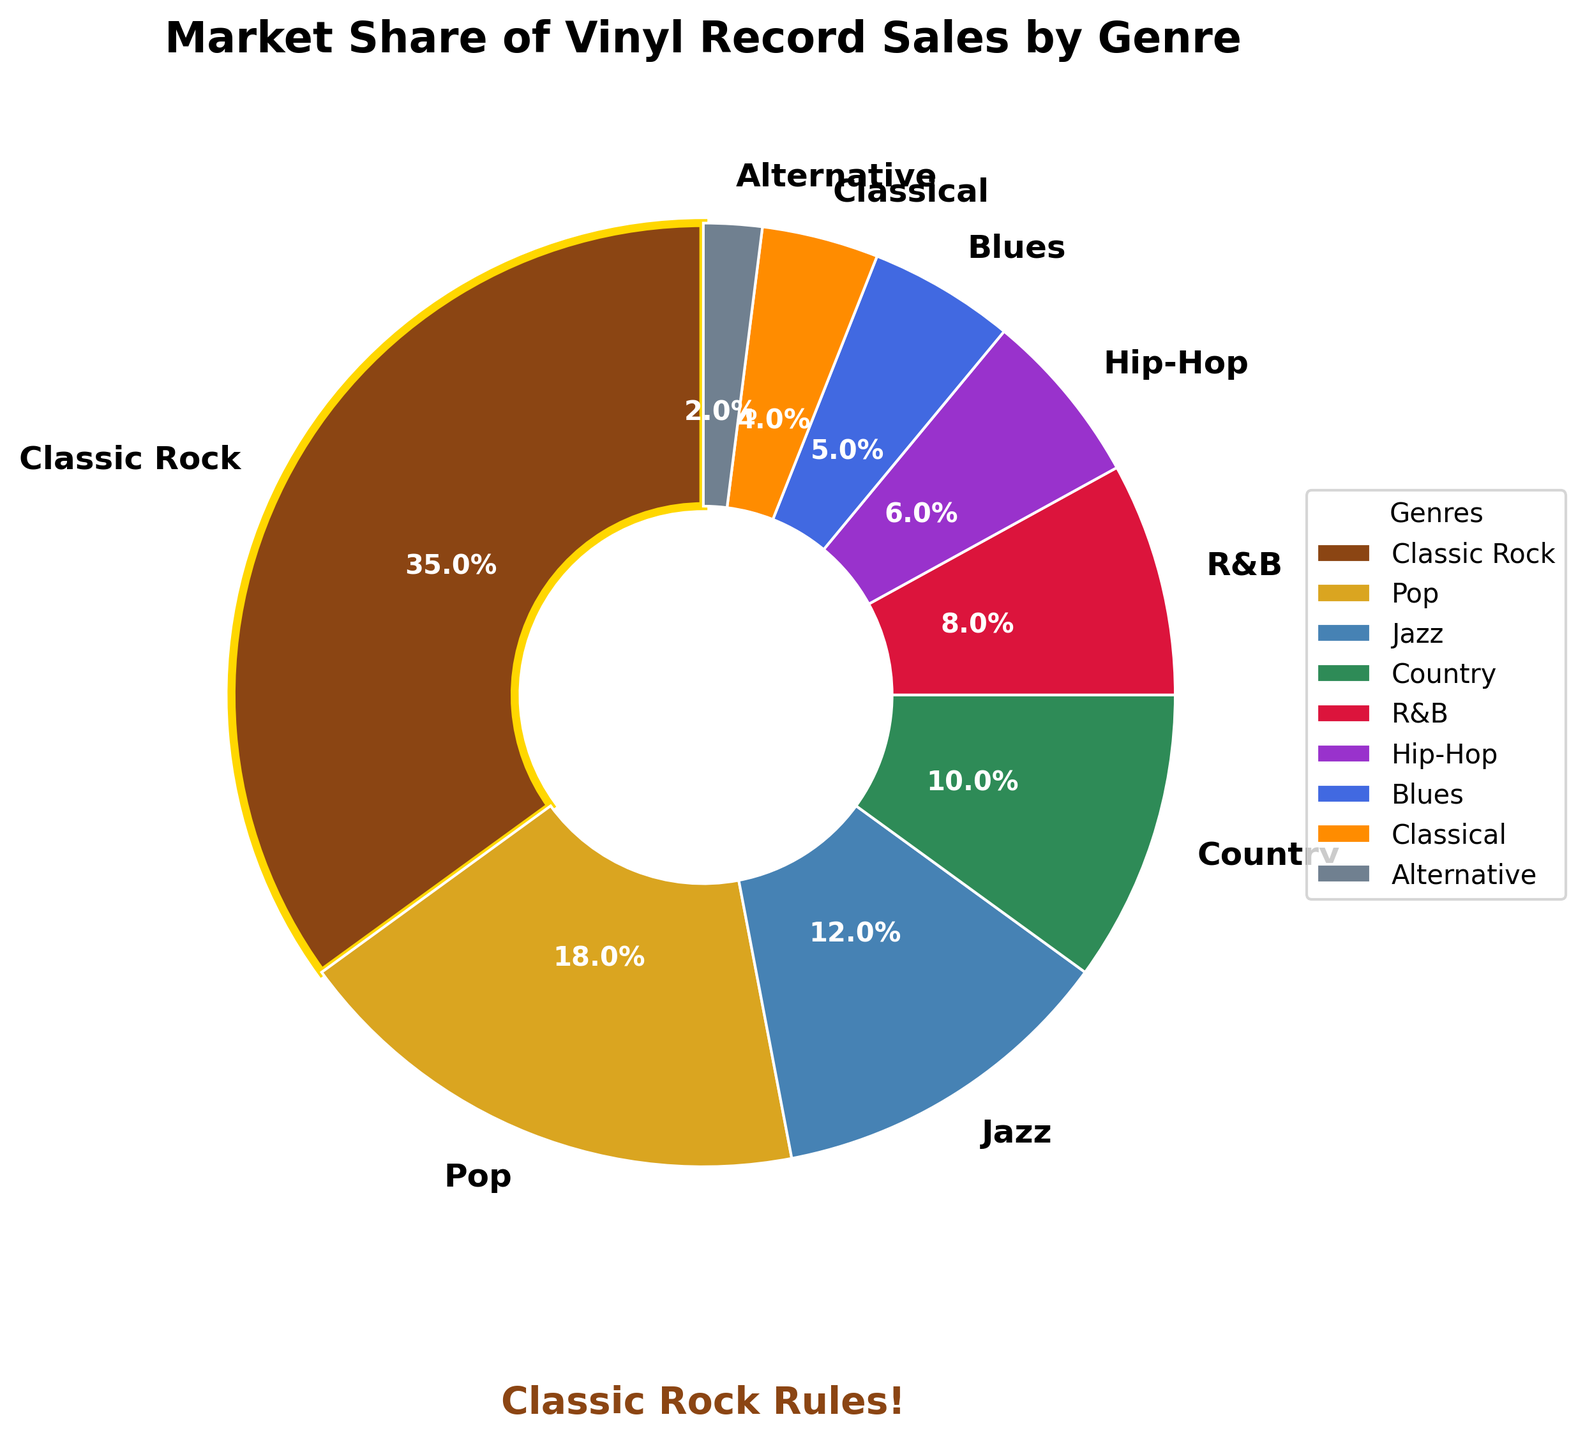Which genre has the largest market share? The pie chart shows that Classic Rock has the largest market share at 35%.
Answer: Classic Rock Which genre has the smallest market share? According to the pie chart, Alternative music has the smallest market share at 2%.
Answer: Alternative What is the combined market share of Jazz and Blues? Jazz has a market share of 12% and Blues has 5%. Combining these gives us 12% + 5% = 17%.
Answer: 17% How does the market share of Pop compare to that of Hip-Hop? The market share of Pop is 18%, and that of Hip-Hop is 6%. Therefore, Pop's market share is larger than Hip-Hop's.
Answer: Pop's share is larger What percentage of the market is covered by genres other than Classic Rock? Classic Rock has a market share of 35%. Subtracting this from 100% gives us 100% - 35% = 65%.
Answer: 65% Which two genres have the combined market share closest to Classic Rock's? The combined market shares of Pop (18%) and Jazz (12%) add up to 18% + 12% = 30%, which is the closest to Classic Rock's 35%.
Answer: Pop and Jazz Among Country and Classical music, which has the higher market share? Country has a market share of 10%, while Classical has 4%. Therefore, Country has the higher market share.
Answer: Country What is the sum of the market shares of R&B, Hip-Hop, and Blues? R&B has 8%, Hip-Hop has 6%, and Blues has 5%. Adding these together gives 8% + 6% + 5% = 19%.
Answer: 19% Is there any wedge highlighted differently? If yes, which one and how? Yes, the wedge for Classic Rock is highlighted with a bold gold-colored edge.
Answer: Classic Rock What's the visual indication that Classic Rock is a favorite genre? The text "Classic Rock Rules!" with a bold brown font is placed below the pie chart, indicating a special preference for Classic Rock.
Answer: Text below the chart 